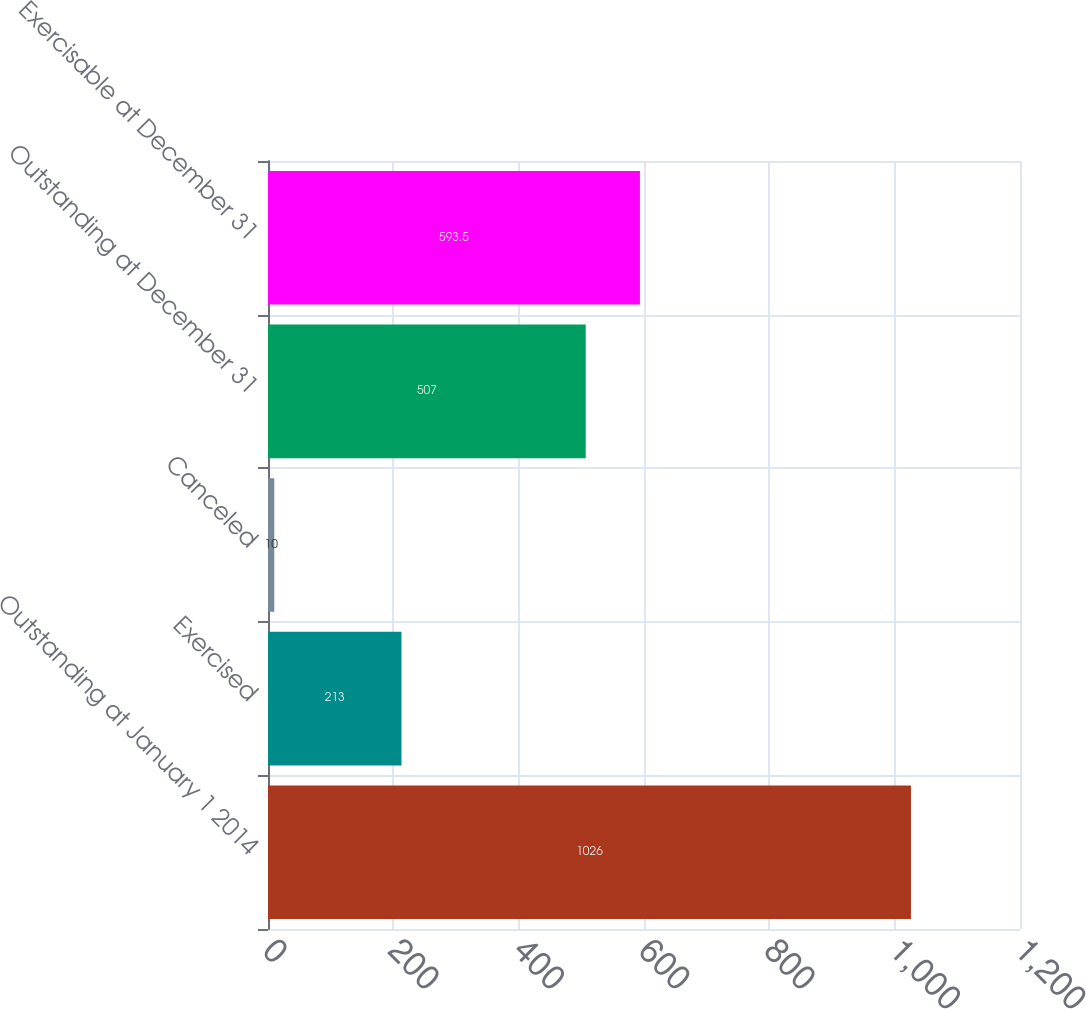Convert chart to OTSL. <chart><loc_0><loc_0><loc_500><loc_500><bar_chart><fcel>Outstanding at January 1 2014<fcel>Exercised<fcel>Canceled<fcel>Outstanding at December 31<fcel>Exercisable at December 31<nl><fcel>1026<fcel>213<fcel>10<fcel>507<fcel>593.5<nl></chart> 